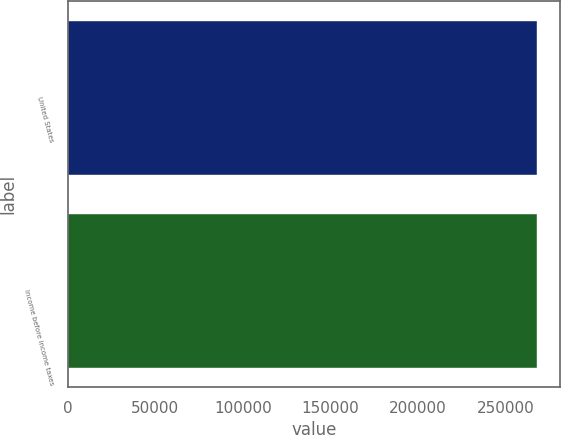Convert chart to OTSL. <chart><loc_0><loc_0><loc_500><loc_500><bar_chart><fcel>United States<fcel>Income before income taxes<nl><fcel>267696<fcel>267696<nl></chart> 